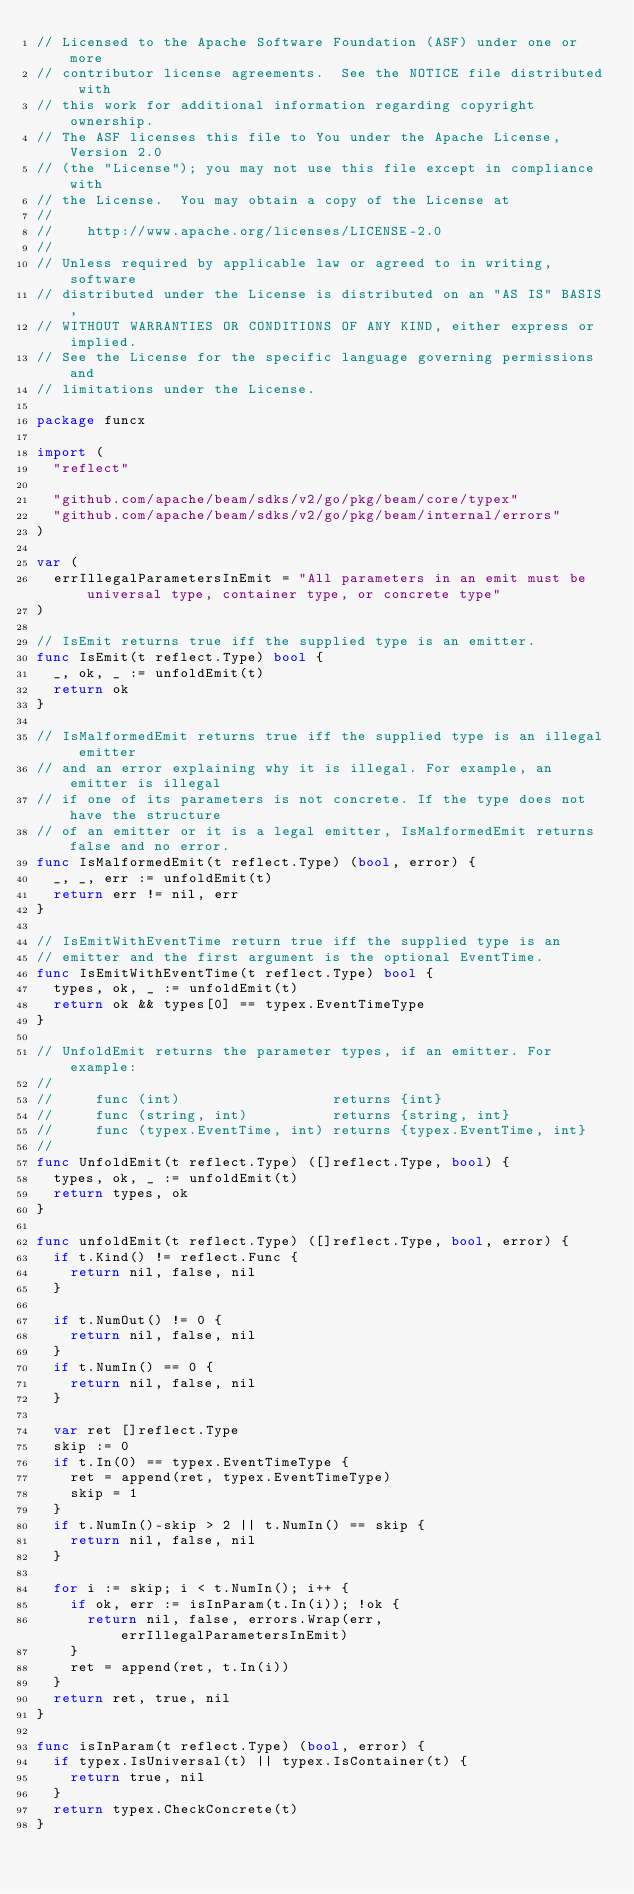<code> <loc_0><loc_0><loc_500><loc_500><_Go_>// Licensed to the Apache Software Foundation (ASF) under one or more
// contributor license agreements.  See the NOTICE file distributed with
// this work for additional information regarding copyright ownership.
// The ASF licenses this file to You under the Apache License, Version 2.0
// (the "License"); you may not use this file except in compliance with
// the License.  You may obtain a copy of the License at
//
//    http://www.apache.org/licenses/LICENSE-2.0
//
// Unless required by applicable law or agreed to in writing, software
// distributed under the License is distributed on an "AS IS" BASIS,
// WITHOUT WARRANTIES OR CONDITIONS OF ANY KIND, either express or implied.
// See the License for the specific language governing permissions and
// limitations under the License.

package funcx

import (
	"reflect"

	"github.com/apache/beam/sdks/v2/go/pkg/beam/core/typex"
	"github.com/apache/beam/sdks/v2/go/pkg/beam/internal/errors"
)

var (
	errIllegalParametersInEmit = "All parameters in an emit must be universal type, container type, or concrete type"
)

// IsEmit returns true iff the supplied type is an emitter.
func IsEmit(t reflect.Type) bool {
	_, ok, _ := unfoldEmit(t)
	return ok
}

// IsMalformedEmit returns true iff the supplied type is an illegal emitter
// and an error explaining why it is illegal. For example, an emitter is illegal
// if one of its parameters is not concrete. If the type does not have the structure
// of an emitter or it is a legal emitter, IsMalformedEmit returns false and no error.
func IsMalformedEmit(t reflect.Type) (bool, error) {
	_, _, err := unfoldEmit(t)
	return err != nil, err
}

// IsEmitWithEventTime return true iff the supplied type is an
// emitter and the first argument is the optional EventTime.
func IsEmitWithEventTime(t reflect.Type) bool {
	types, ok, _ := unfoldEmit(t)
	return ok && types[0] == typex.EventTimeType
}

// UnfoldEmit returns the parameter types, if an emitter. For example:
//
//     func (int)                  returns {int}
//     func (string, int)          returns {string, int}
//     func (typex.EventTime, int) returns {typex.EventTime, int}
//
func UnfoldEmit(t reflect.Type) ([]reflect.Type, bool) {
	types, ok, _ := unfoldEmit(t)
	return types, ok
}

func unfoldEmit(t reflect.Type) ([]reflect.Type, bool, error) {
	if t.Kind() != reflect.Func {
		return nil, false, nil
	}

	if t.NumOut() != 0 {
		return nil, false, nil
	}
	if t.NumIn() == 0 {
		return nil, false, nil
	}

	var ret []reflect.Type
	skip := 0
	if t.In(0) == typex.EventTimeType {
		ret = append(ret, typex.EventTimeType)
		skip = 1
	}
	if t.NumIn()-skip > 2 || t.NumIn() == skip {
		return nil, false, nil
	}

	for i := skip; i < t.NumIn(); i++ {
		if ok, err := isInParam(t.In(i)); !ok {
			return nil, false, errors.Wrap(err, errIllegalParametersInEmit)
		}
		ret = append(ret, t.In(i))
	}
	return ret, true, nil
}

func isInParam(t reflect.Type) (bool, error) {
	if typex.IsUniversal(t) || typex.IsContainer(t) {
		return true, nil
	}
	return typex.CheckConcrete(t)
}
</code> 